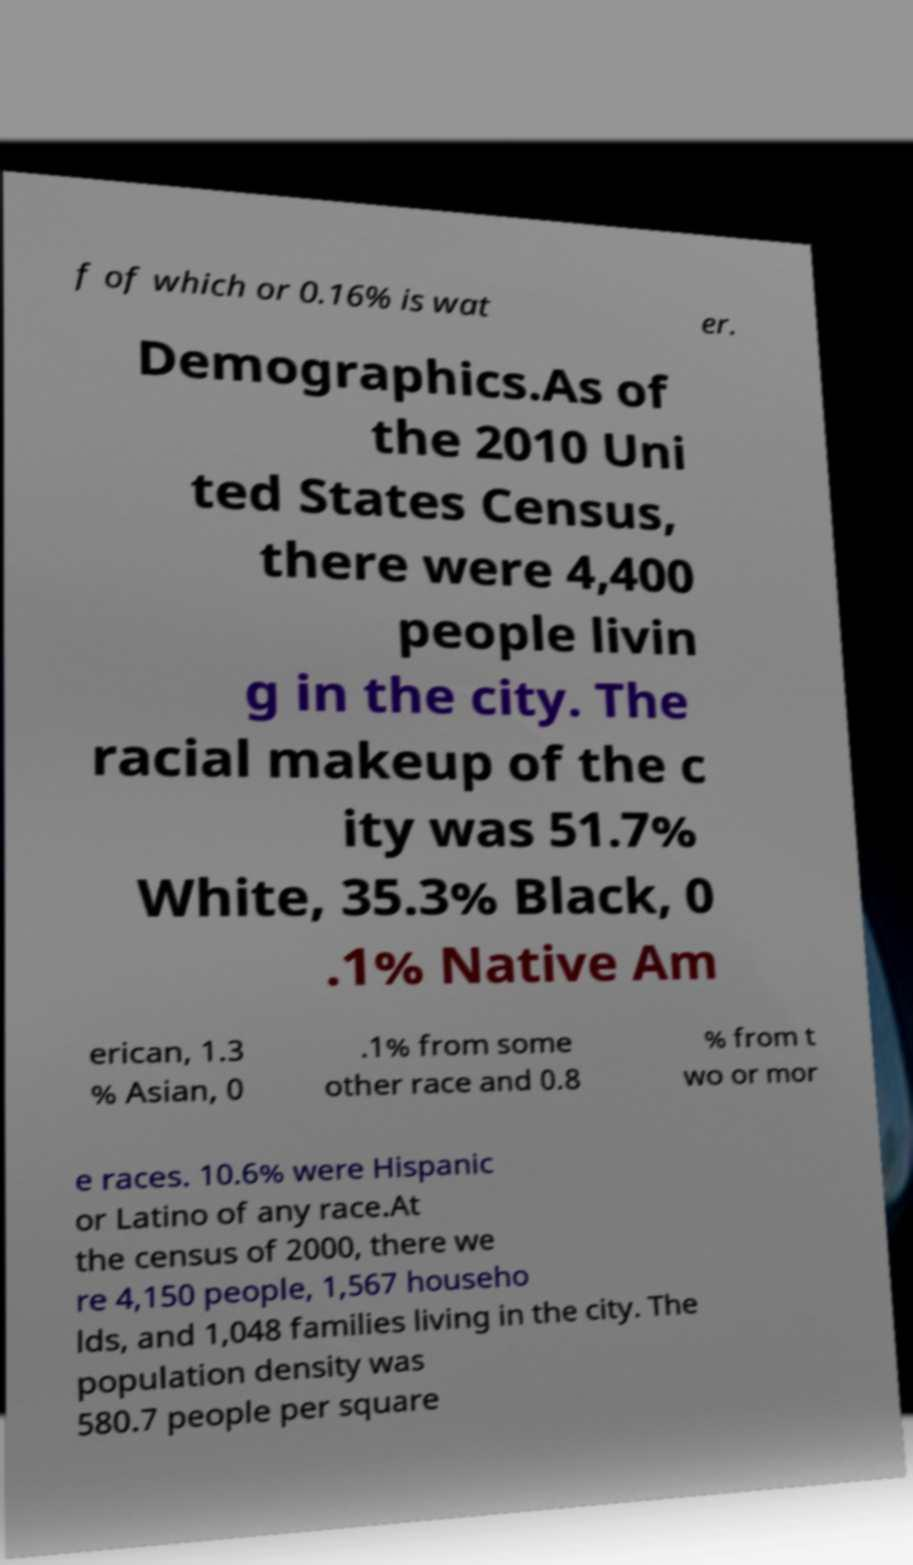For documentation purposes, I need the text within this image transcribed. Could you provide that? f of which or 0.16% is wat er. Demographics.As of the 2010 Uni ted States Census, there were 4,400 people livin g in the city. The racial makeup of the c ity was 51.7% White, 35.3% Black, 0 .1% Native Am erican, 1.3 % Asian, 0 .1% from some other race and 0.8 % from t wo or mor e races. 10.6% were Hispanic or Latino of any race.At the census of 2000, there we re 4,150 people, 1,567 househo lds, and 1,048 families living in the city. The population density was 580.7 people per square 